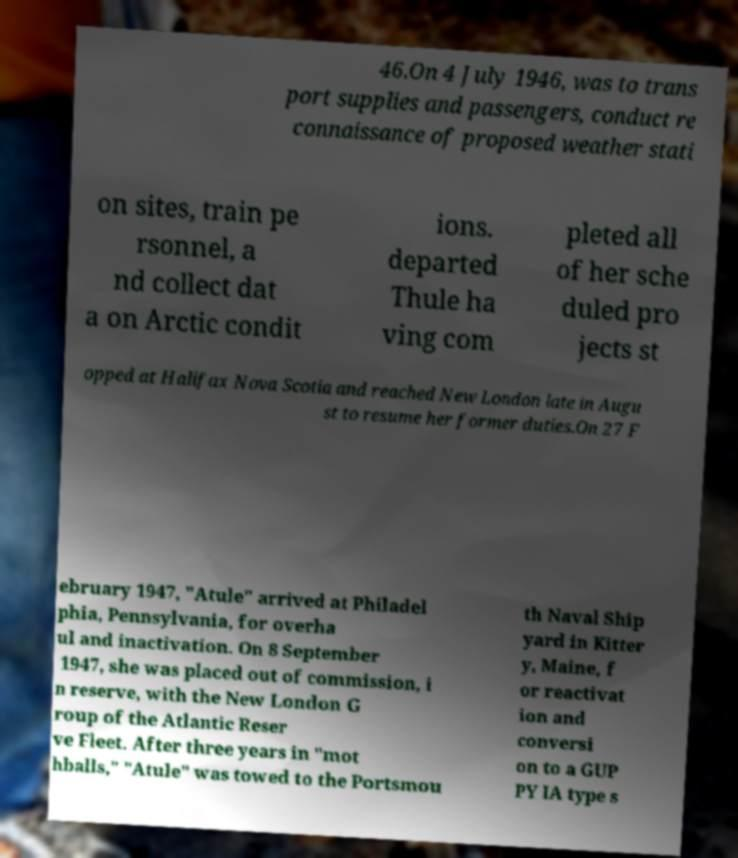For documentation purposes, I need the text within this image transcribed. Could you provide that? 46.On 4 July 1946, was to trans port supplies and passengers, conduct re connaissance of proposed weather stati on sites, train pe rsonnel, a nd collect dat a on Arctic condit ions. departed Thule ha ving com pleted all of her sche duled pro jects st opped at Halifax Nova Scotia and reached New London late in Augu st to resume her former duties.On 27 F ebruary 1947, "Atule" arrived at Philadel phia, Pennsylvania, for overha ul and inactivation. On 8 September 1947, she was placed out of commission, i n reserve, with the New London G roup of the Atlantic Reser ve Fleet. After three years in "mot hballs," "Atule" was towed to the Portsmou th Naval Ship yard in Kitter y, Maine, f or reactivat ion and conversi on to a GUP PY IA type s 